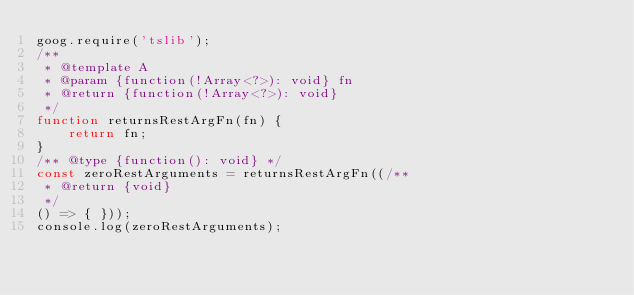Convert code to text. <code><loc_0><loc_0><loc_500><loc_500><_JavaScript_>goog.require('tslib');
/**
 * @template A
 * @param {function(!Array<?>): void} fn
 * @return {function(!Array<?>): void}
 */
function returnsRestArgFn(fn) {
    return fn;
}
/** @type {function(): void} */
const zeroRestArguments = returnsRestArgFn((/**
 * @return {void}
 */
() => { }));
console.log(zeroRestArguments);
</code> 